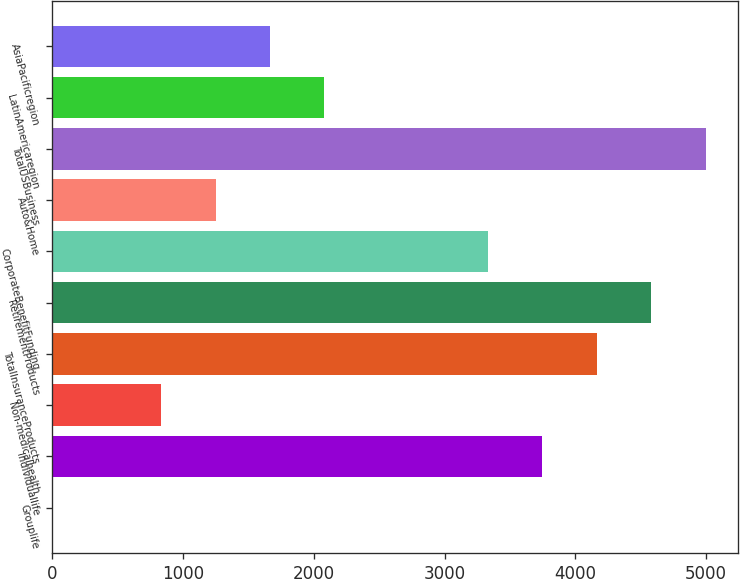Convert chart. <chart><loc_0><loc_0><loc_500><loc_500><bar_chart><fcel>Grouplife<fcel>Individuallife<fcel>Non-medicalhealth<fcel>TotalInsuranceProducts<fcel>RetirementProducts<fcel>CorporateBenefitFunding<fcel>Auto&Home<fcel>TotalUSBusiness<fcel>LatinAmericaregion<fcel>AsiaPacificregion<nl><fcel>2<fcel>3746.9<fcel>834.2<fcel>4163<fcel>4579.1<fcel>3330.8<fcel>1250.3<fcel>4995.2<fcel>2082.5<fcel>1666.4<nl></chart> 